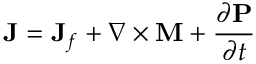<formula> <loc_0><loc_0><loc_500><loc_500>J = J _ { f } + \nabla \times M + { \frac { \partial P } { \partial t } }</formula> 